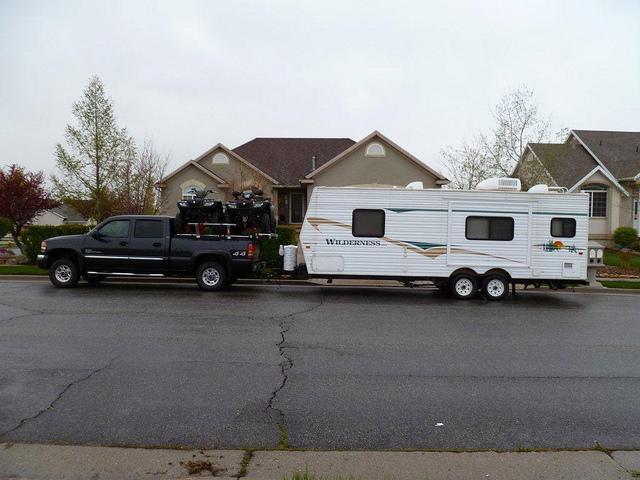How many axles does the trailer have?
Give a very brief answer. 2. How many tires are visible?
Give a very brief answer. 4. How many trucks are outside?
Give a very brief answer. 1. How many trucks are there?
Give a very brief answer. 2. 